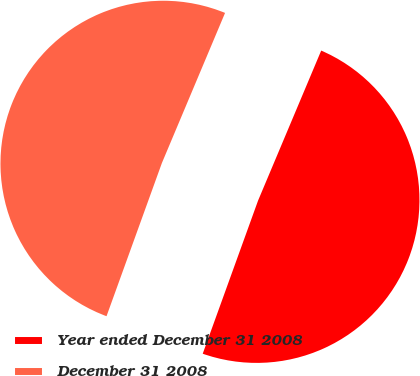<chart> <loc_0><loc_0><loc_500><loc_500><pie_chart><fcel>Year ended December 31 2008<fcel>December 31 2008<nl><fcel>49.18%<fcel>50.82%<nl></chart> 